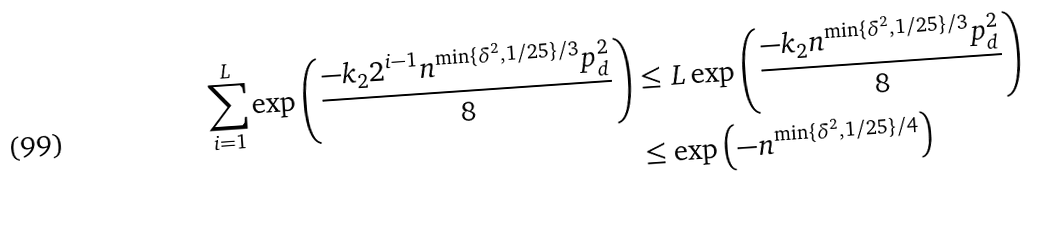Convert formula to latex. <formula><loc_0><loc_0><loc_500><loc_500>\sum _ { i = 1 } ^ { L } \exp \left ( \frac { - k _ { 2 } 2 ^ { i - 1 } n ^ { \min \{ \delta ^ { 2 } , 1 / 2 5 \} / 3 } p _ { d } ^ { 2 } } { 8 } \right ) & \leq L \exp \left ( \frac { - k _ { 2 } n ^ { \min \{ \delta ^ { 2 } , 1 / 2 5 \} / 3 } p _ { d } ^ { 2 } } { 8 } \right ) \\ & \leq \exp \left ( - n ^ { \min \{ \delta ^ { 2 } , 1 / 2 5 \} / 4 } \right )</formula> 